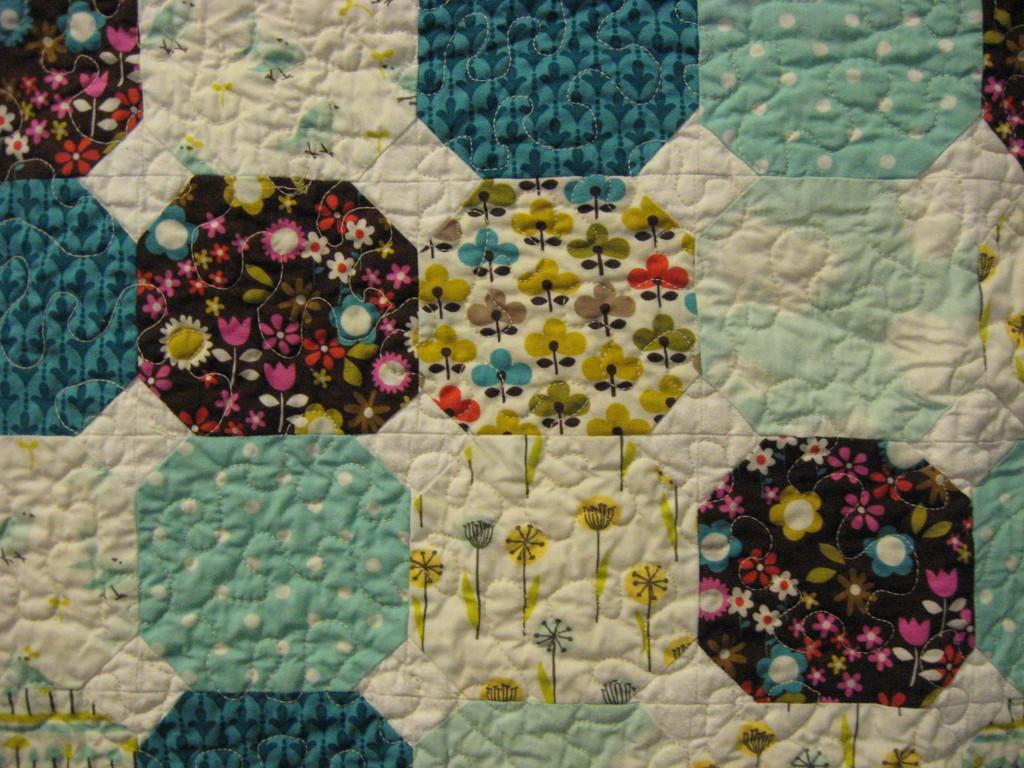Could you give a brief overview of what you see in this image? In this image, we can see different types of designs. 